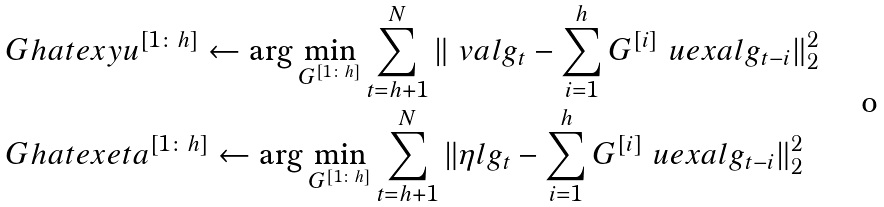<formula> <loc_0><loc_0><loc_500><loc_500>& \ G h a t e x y u ^ { [ 1 \colon h ] } \leftarrow \arg \min _ { G ^ { [ 1 \colon h ] } } \sum _ { t = h + 1 } ^ { N } \| \ v a l g _ { t } - \sum _ { i = 1 } ^ { h } G ^ { [ i ] } \ u e x a l g _ { t - i } \| _ { 2 } ^ { 2 } \\ & \ G h a t e x e t a ^ { [ 1 \colon h ] } \leftarrow \arg \min _ { G ^ { [ 1 \colon h ] } } \sum _ { t = h + 1 } ^ { N } \| \eta l g _ { t } - \sum _ { i = 1 } ^ { h } G ^ { [ i ] } \ u e x a l g _ { t - i } \| _ { 2 } ^ { 2 }</formula> 